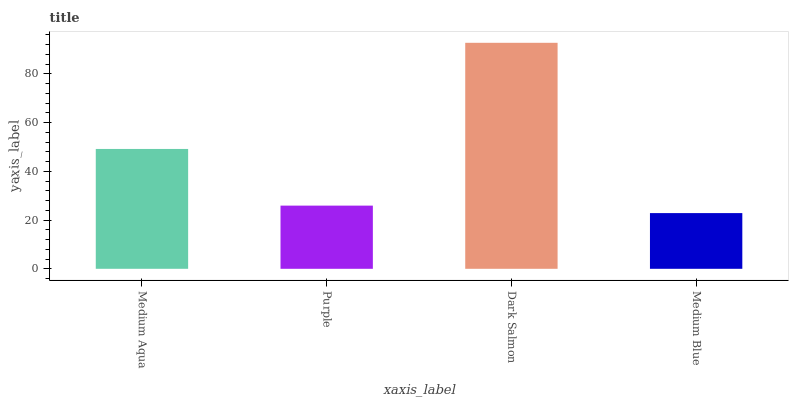Is Medium Blue the minimum?
Answer yes or no. Yes. Is Dark Salmon the maximum?
Answer yes or no. Yes. Is Purple the minimum?
Answer yes or no. No. Is Purple the maximum?
Answer yes or no. No. Is Medium Aqua greater than Purple?
Answer yes or no. Yes. Is Purple less than Medium Aqua?
Answer yes or no. Yes. Is Purple greater than Medium Aqua?
Answer yes or no. No. Is Medium Aqua less than Purple?
Answer yes or no. No. Is Medium Aqua the high median?
Answer yes or no. Yes. Is Purple the low median?
Answer yes or no. Yes. Is Medium Blue the high median?
Answer yes or no. No. Is Medium Aqua the low median?
Answer yes or no. No. 